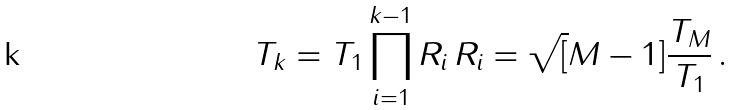Convert formula to latex. <formula><loc_0><loc_0><loc_500><loc_500>T _ { k } = T _ { 1 } \prod _ { i = 1 } ^ { k - 1 } R _ { i } \, R _ { i } = \sqrt { [ } M - 1 ] { \frac { T _ { M } } { T _ { 1 } } } \, .</formula> 